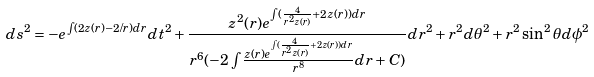Convert formula to latex. <formula><loc_0><loc_0><loc_500><loc_500>d s ^ { 2 } = - e ^ { \int ( 2 z ( r ) - 2 / r ) d r } d t ^ { 2 } + \frac { z ^ { 2 } ( r ) e ^ { \int ( \frac { 4 } { r ^ { 2 } z ( r ) } + 2 z ( r ) ) d r } } { r ^ { 6 } ( - 2 \int \frac { z ( r ) e ^ { \int ( \frac { 4 } { r ^ { 2 } z ( r ) } + 2 z ( r ) ) d r } } { r ^ { 8 } } d r + C ) } d r ^ { 2 } + r ^ { 2 } d \theta ^ { 2 } + r ^ { 2 } \sin ^ { 2 } \theta d \phi ^ { 2 }</formula> 